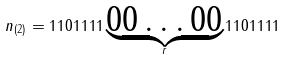<formula> <loc_0><loc_0><loc_500><loc_500>n _ { ( 2 ) } = 1 1 0 1 1 1 1 \underbrace { 0 0 \dots 0 0 } _ { r } 1 1 0 1 1 1 1</formula> 